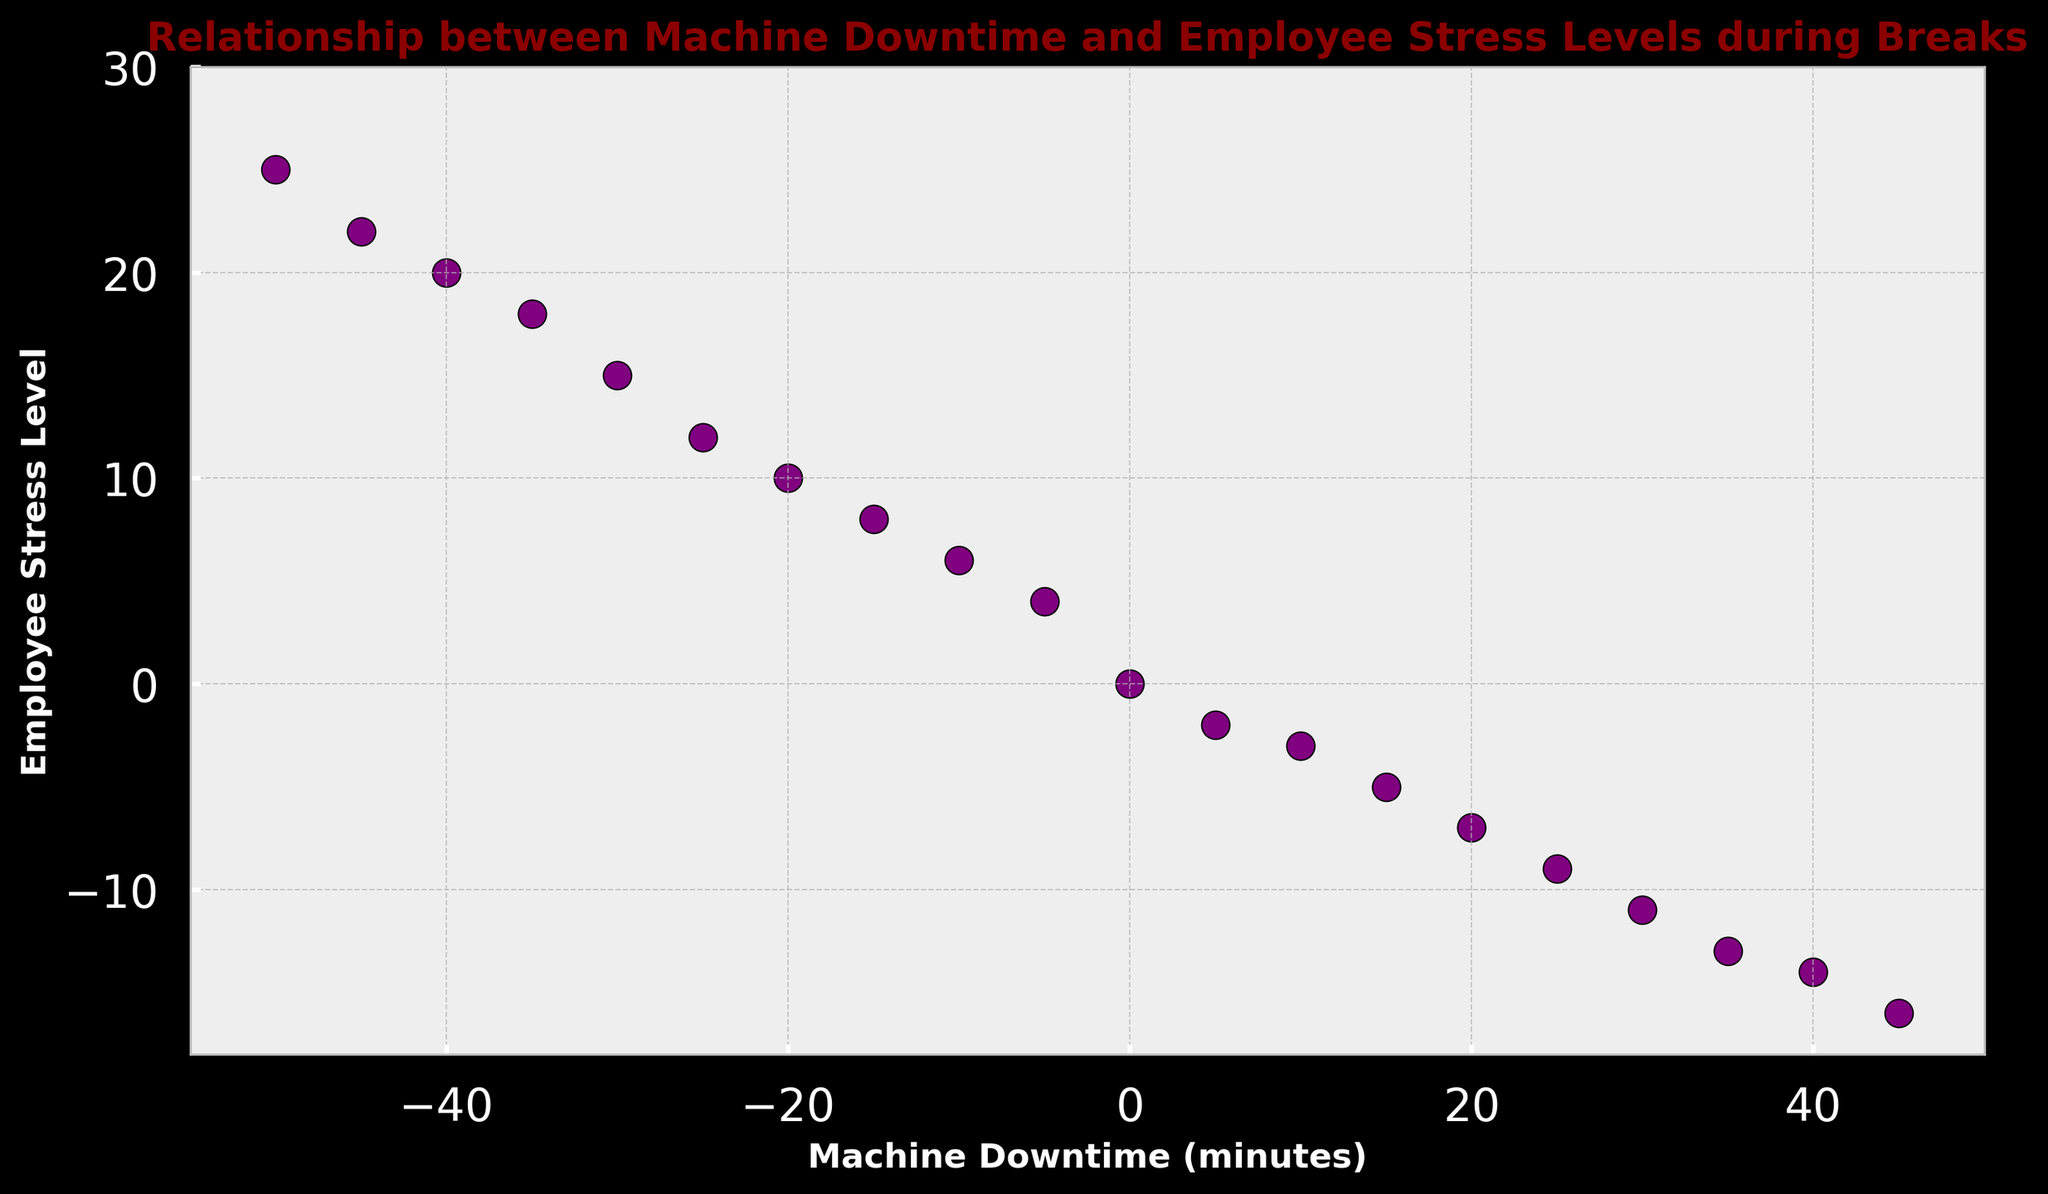what is the range of Machine Downtime values in the plot? The range of Machine Downtime values is determined by finding the minimum and maximum values on the horizontal axis. The minimum Machine Downtime value is -50, and the maximum value is 45. Therefore, the range is 45 - (-50) = 95.
Answer: 95 What is the correlation between Machine Downtime and Employee Stress Levels? By visually inspecting the scatter plot, we can observe that lower Machine Downtime values (high negative numbers) are associated with higher Employee Stress Levels, while higher Machine Downtime values (positive numbers) are associated with lower Employee Stress Levels. This suggests a negative correlation between Machine Downtime and Employee Stress Levels.
Answer: Negative Correlation Which scatter point represents the highest Employee Stress Level? The scatter point representing the highest Employee Stress Level is at the maximum vertical position. The highest Employee Stress Level is 25, which corresponds to a Machine Downtime of -50.
Answer: (Machine Downtime: -50, Employee Stress Level: 25) Are there any points where both Machine Downtime and Employee Stress Levels are zero? To determine this, we look for a scatter point positioned at the origin (0,0). The plot shows a point at (0,0) where both Machine Downtime and Employee Stress Levels are zero.
Answer: Yes What is the difference in Employee Stress Levels between the highest and lowest Machine Downtime values? The highest Machine Downtime value is 45, with an Employee Stress Level of -16. The lowest Machine Downtime value is -50, with an Employee Stress Level of 25. The difference in Employee Stress Levels is 25 - (-16) = 41.
Answer: 41 Which Machine Downtime value has the lowest Employee Stress Level? By identifying the scatter point with the lowest vertical position, we find the lowest Employee Stress Level to be -16, which corresponds to a Machine Downtime of 45.
Answer: 45 Does increasing Machine Downtime always result in decreasing Employee Stress Levels? Observing the scatter plot, we notice that there is a general negative correlation, but it is not a perfect relationship. Most points follow this trend, but there are some exceptions where increases in Machine Downtime do not result in decreases in Employee Stress Levels.
Answer: No What is the average Machine Downtime for Employee Stress Levels greater than 10? The points with Employee Stress Levels greater than 10 are -20 (10), -25 (12), -30 (15), -35 (18), -40 (20), -45 (22), and -50 (25). The average Machine Downtime is (-20 - 25 - 30 - 35 - 40 - 45 - 50)/7 = -245/7 = -35.
Answer: -35 